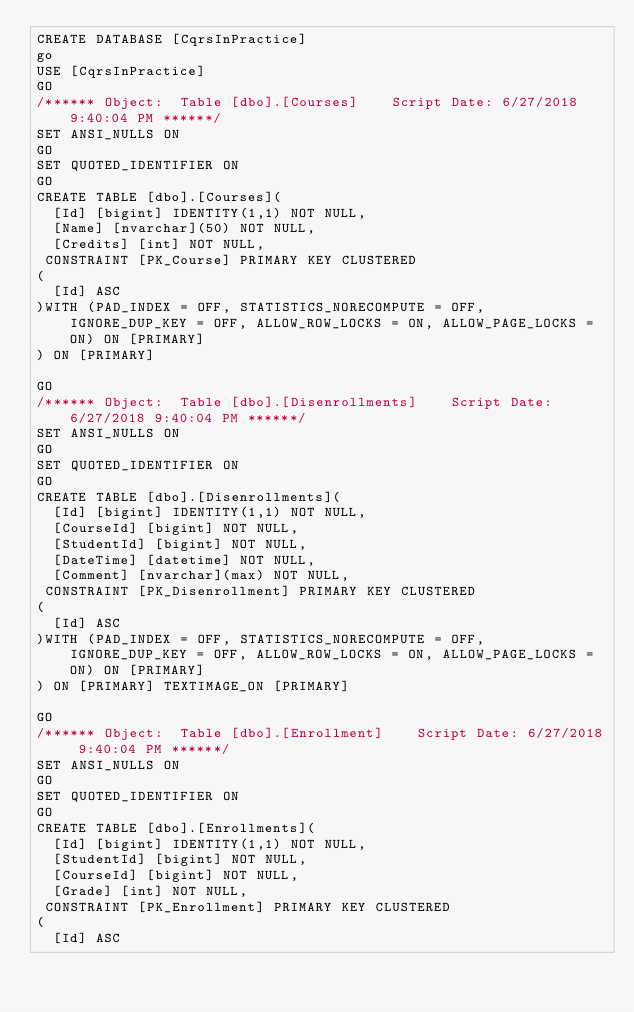Convert code to text. <code><loc_0><loc_0><loc_500><loc_500><_SQL_>CREATE DATABASE [CqrsInPractice]
go
USE [CqrsInPractice]
GO
/****** Object:  Table [dbo].[Courses]    Script Date: 6/27/2018 9:40:04 PM ******/
SET ANSI_NULLS ON
GO
SET QUOTED_IDENTIFIER ON
GO
CREATE TABLE [dbo].[Courses](
	[Id] [bigint] IDENTITY(1,1) NOT NULL,
	[Name] [nvarchar](50) NOT NULL,
	[Credits] [int] NOT NULL,
 CONSTRAINT [PK_Course] PRIMARY KEY CLUSTERED 
(
	[Id] ASC
)WITH (PAD_INDEX = OFF, STATISTICS_NORECOMPUTE = OFF, IGNORE_DUP_KEY = OFF, ALLOW_ROW_LOCKS = ON, ALLOW_PAGE_LOCKS = ON) ON [PRIMARY]
) ON [PRIMARY]

GO
/****** Object:  Table [dbo].[Disenrollments]    Script Date: 6/27/2018 9:40:04 PM ******/
SET ANSI_NULLS ON
GO
SET QUOTED_IDENTIFIER ON
GO
CREATE TABLE [dbo].[Disenrollments](
	[Id] [bigint] IDENTITY(1,1) NOT NULL,
	[CourseId] [bigint] NOT NULL,
	[StudentId] [bigint] NOT NULL,
	[DateTime] [datetime] NOT NULL,
	[Comment] [nvarchar](max) NOT NULL,
 CONSTRAINT [PK_Disenrollment] PRIMARY KEY CLUSTERED 
(
	[Id] ASC
)WITH (PAD_INDEX = OFF, STATISTICS_NORECOMPUTE = OFF, IGNORE_DUP_KEY = OFF, ALLOW_ROW_LOCKS = ON, ALLOW_PAGE_LOCKS = ON) ON [PRIMARY]
) ON [PRIMARY] TEXTIMAGE_ON [PRIMARY]

GO
/****** Object:  Table [dbo].[Enrollment]    Script Date: 6/27/2018 9:40:04 PM ******/
SET ANSI_NULLS ON
GO
SET QUOTED_IDENTIFIER ON
GO
CREATE TABLE [dbo].[Enrollments](
	[Id] [bigint] IDENTITY(1,1) NOT NULL,
	[StudentId] [bigint] NOT NULL,
	[CourseId] [bigint] NOT NULL,
	[Grade] [int] NOT NULL,
 CONSTRAINT [PK_Enrollment] PRIMARY KEY CLUSTERED 
(
	[Id] ASC</code> 